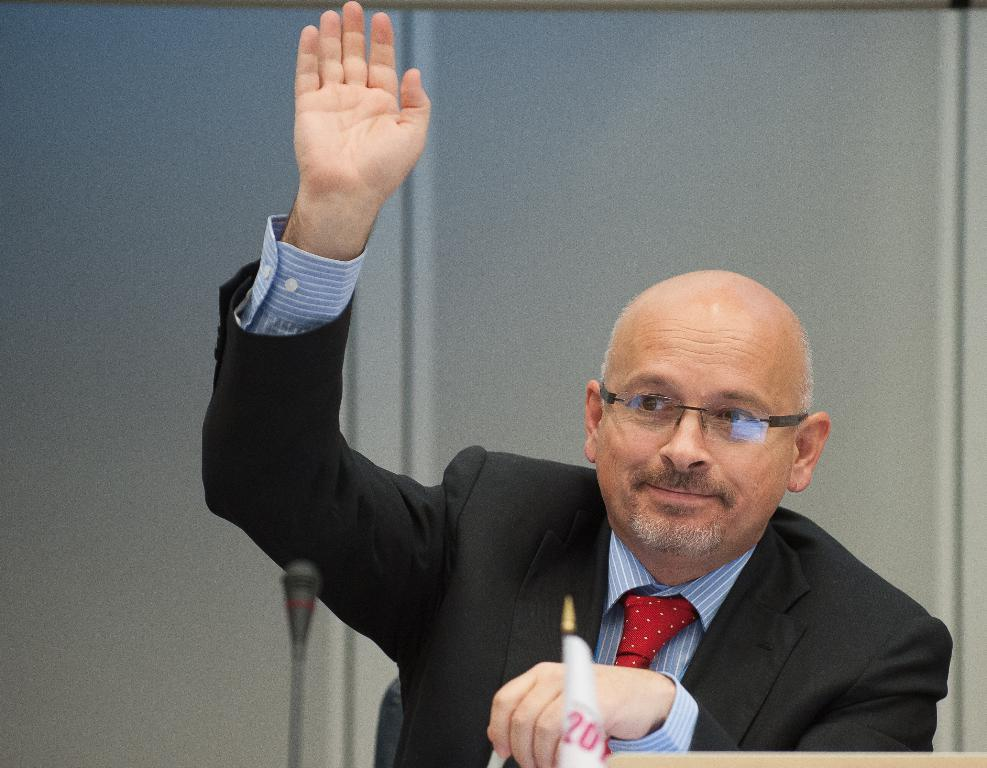What is present in the image? There is a man in the image. What is the man doing with his hand? The man is raising one of his hands. What type of cloud can be seen in the image? There is no cloud present in the image; it only features a man raising one of his hands. How does the bee contribute to the arithmetic in the image? There is no bee or arithmetic present in the image; it only features a man raising one of his hands. 